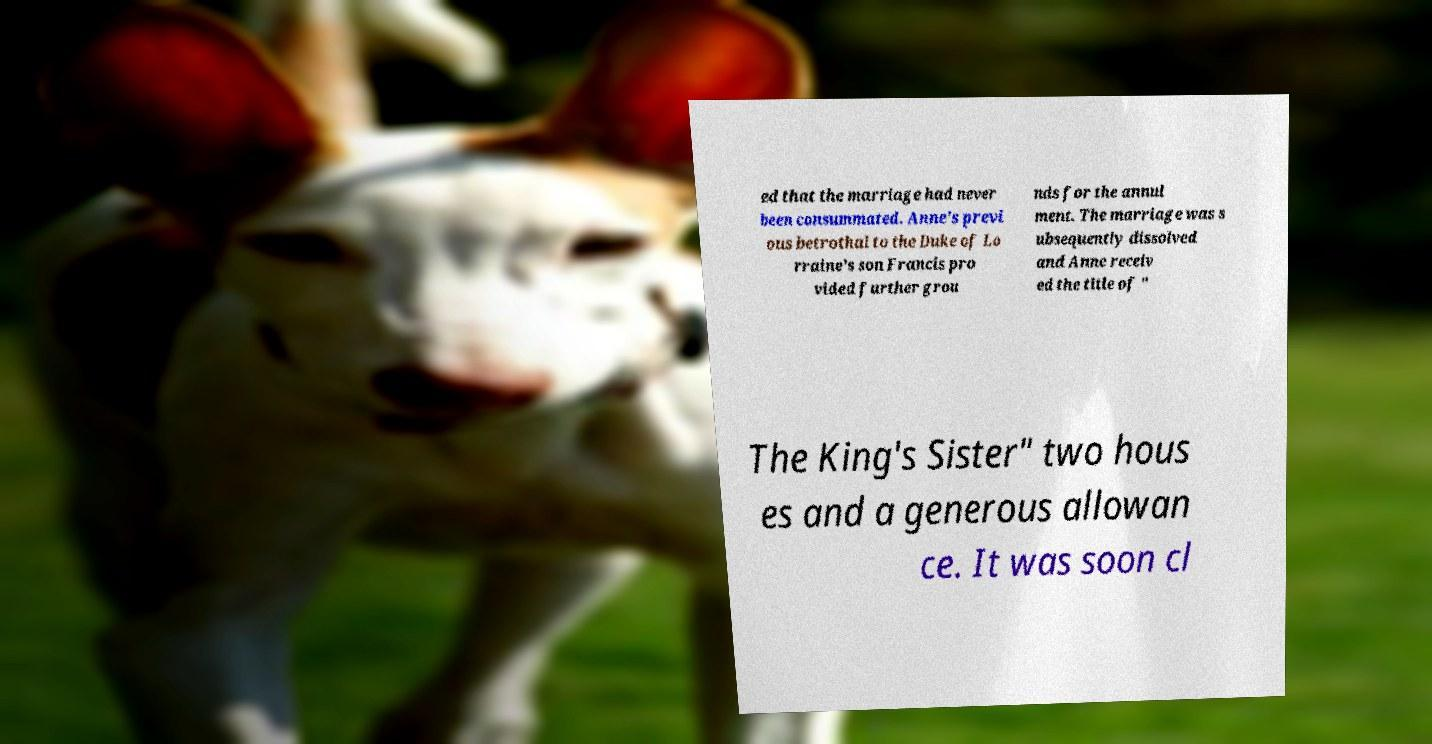There's text embedded in this image that I need extracted. Can you transcribe it verbatim? ed that the marriage had never been consummated. Anne's previ ous betrothal to the Duke of Lo rraine's son Francis pro vided further grou nds for the annul ment. The marriage was s ubsequently dissolved and Anne receiv ed the title of " The King's Sister" two hous es and a generous allowan ce. It was soon cl 